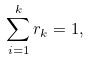<formula> <loc_0><loc_0><loc_500><loc_500>\sum _ { i = 1 } ^ { k } r _ { k } = 1 ,</formula> 